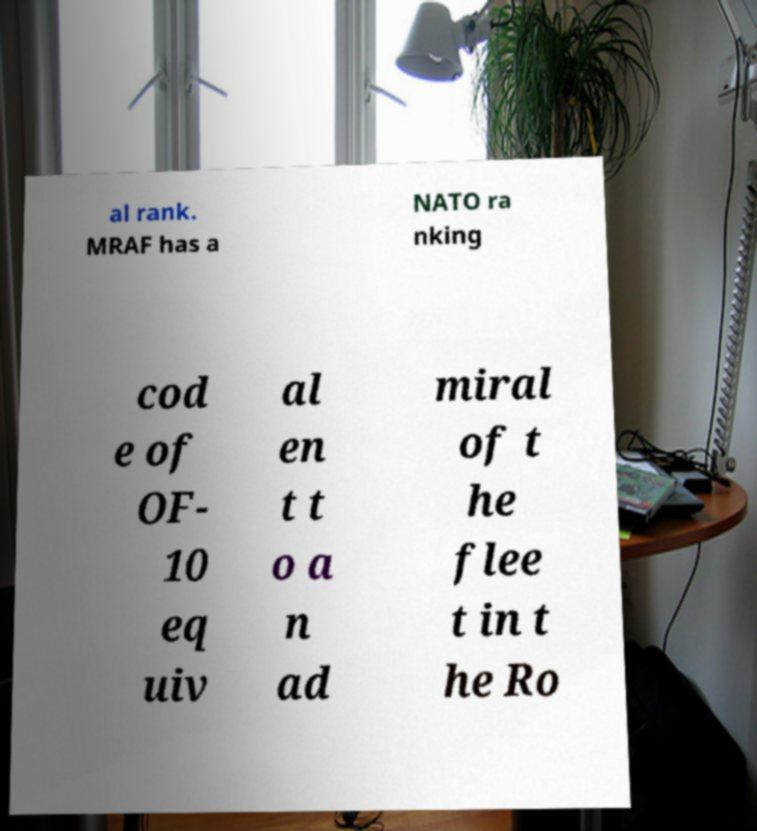Could you extract and type out the text from this image? al rank. MRAF has a NATO ra nking cod e of OF- 10 eq uiv al en t t o a n ad miral of t he flee t in t he Ro 